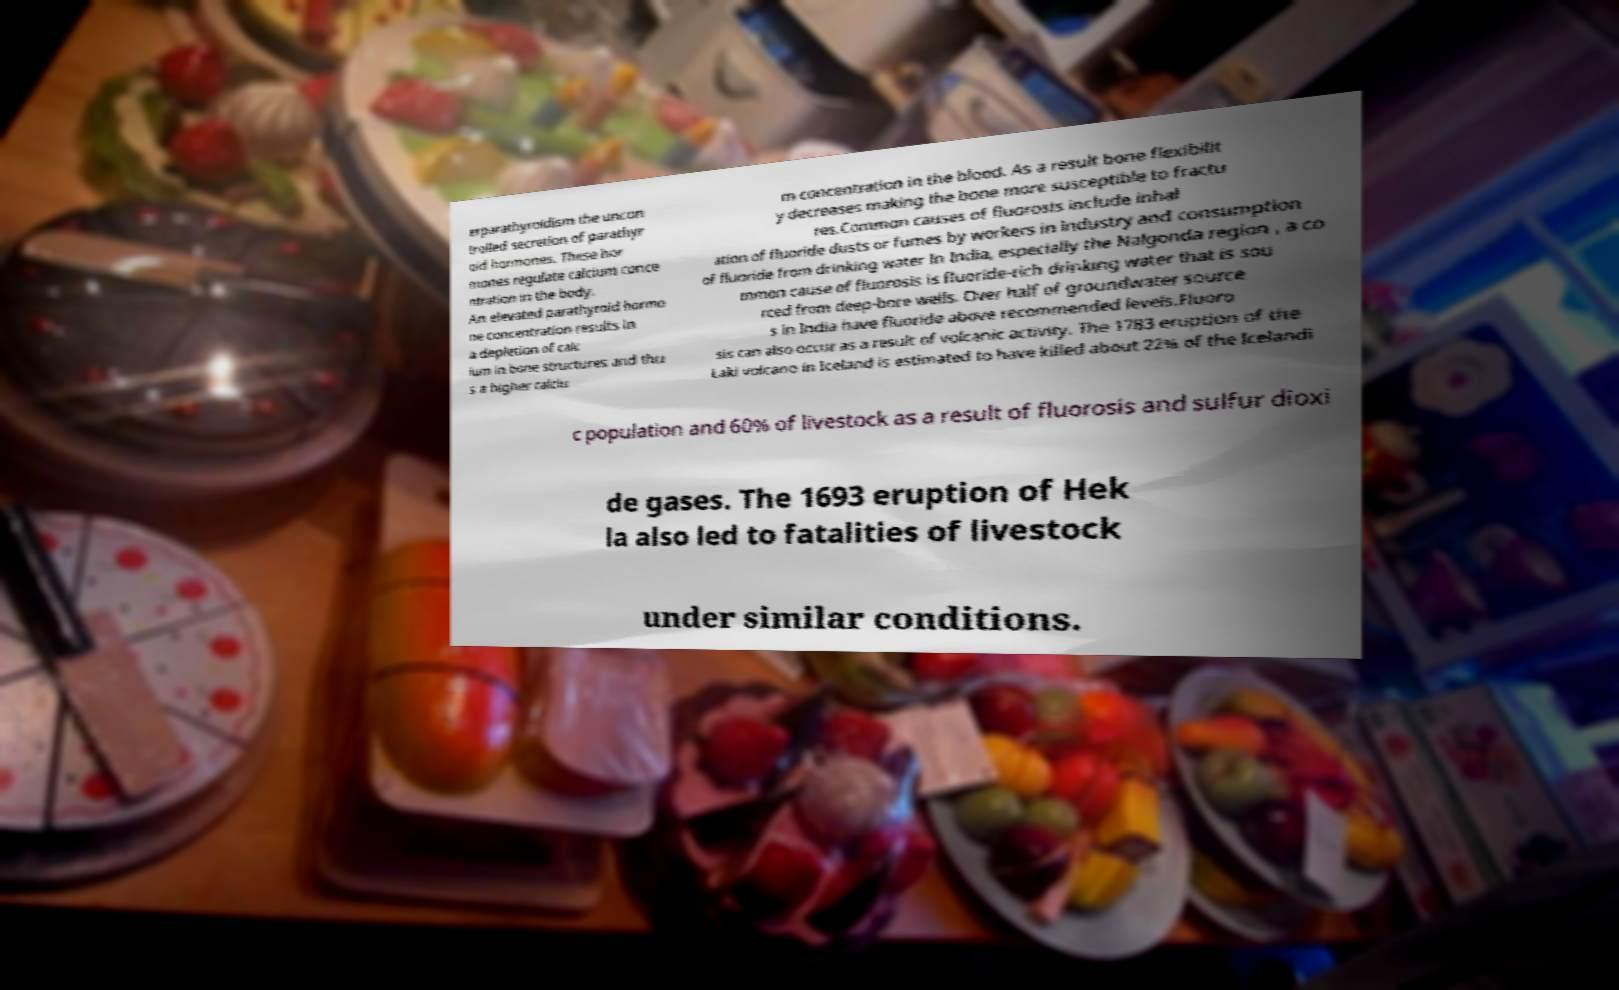Please identify and transcribe the text found in this image. erparathyroidism the uncon trolled secretion of parathyr oid hormones. These hor mones regulate calcium conce ntration in the body. An elevated parathyroid hormo ne concentration results in a depletion of calc ium in bone structures and thu s a higher calciu m concentration in the blood. As a result bone flexibilit y decreases making the bone more susceptible to fractu res.Common causes of fluorosis include inhal ation of fluoride dusts or fumes by workers in industry and consumption of fluoride from drinking water In India, especially the Nalgonda region , a co mmon cause of fluorosis is fluoride-rich drinking water that is sou rced from deep-bore wells. Over half of groundwater source s in India have fluoride above recommended levels.Fluoro sis can also occur as a result of volcanic activity. The 1783 eruption of the Laki volcano in Iceland is estimated to have killed about 22% of the Icelandi c population and 60% of livestock as a result of fluorosis and sulfur dioxi de gases. The 1693 eruption of Hek la also led to fatalities of livestock under similar conditions. 